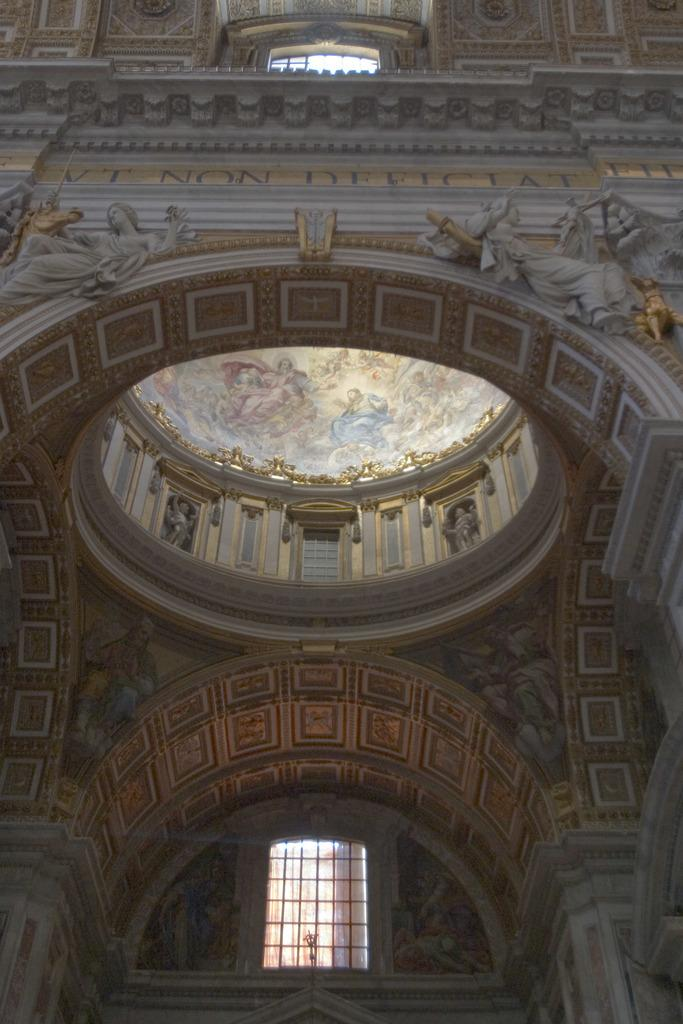What type of structure is depicted in the image? There is a historical monument in the image. How many horses are present in the image? There are no horses present in the image; it features a historical monument. What type of trees can be seen surrounding the monument in the image? There is no information about trees in the image; it only mentions a historical monument. 